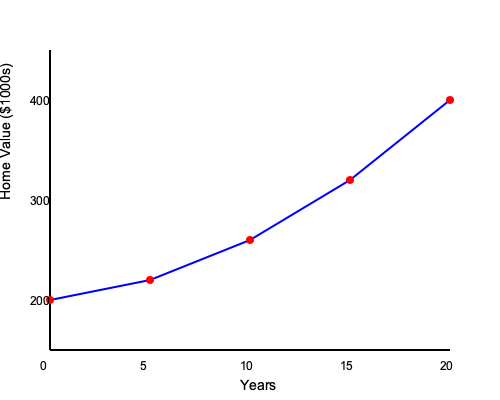As a new homeowner in the neighborhood, you're interested in understanding home value appreciation. The graph shows the estimated value of a home over 20 years. If the trend continues, what would be the approximate value of the home after 25 years, and what is the average annual appreciation rate? To solve this problem, let's follow these steps:

1. Analyze the trend:
   The graph shows a non-linear increase in home value over 20 years.
   Initial value (Year 0): $200,000
   Final value (Year 20): $400,000

2. Estimate the value at 25 years:
   The trend appears to be accelerating, so we can't simply extend the line.
   A reasonable estimate would be around $450,000 to $500,000.

3. Calculate the average annual appreciation rate:
   We'll use the compound annual growth rate (CAGR) formula:
   $CAGR = (Ending Value / Beginning Value)^{(1/n)} - 1$
   Where n is the number of years.

   $CAGR = (400,000 / 200,000)^{(1/20)} - 1$
   $CAGR = 2^{(1/20)} - 1$
   $CAGR = 1.0353 - 1$
   $CAGR = 0.0353$ or 3.53%

4. Convert to a percentage:
   3.53% per year

Therefore, the estimated home value after 25 years would be approximately $475,000, and the average annual appreciation rate is 3.53%.
Answer: $475,000; 3.53% per year 